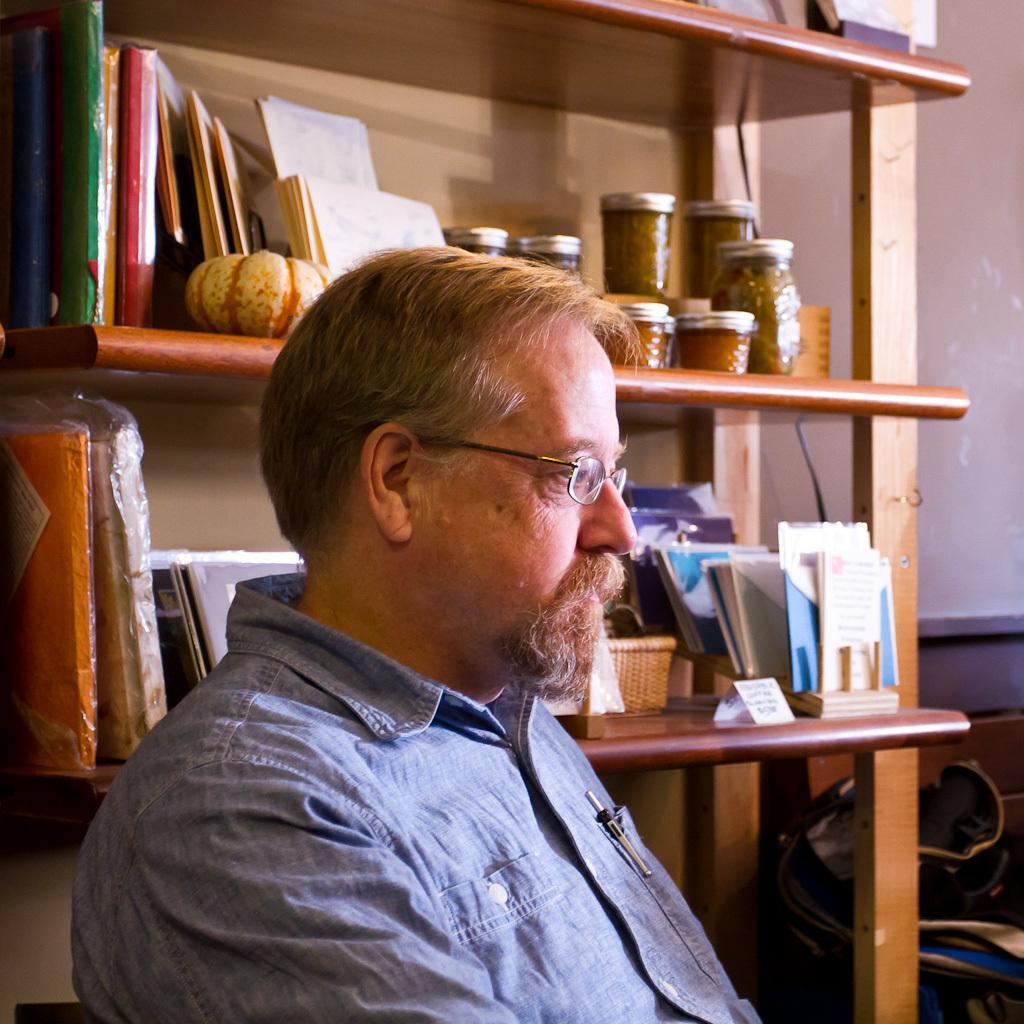How would you summarize this image in a sentence or two? In this picture there is a man wore spectacle, behind him we can see books, pumpkin, board, basket and objects in racks. In the background of the image we can see bag and wall. 